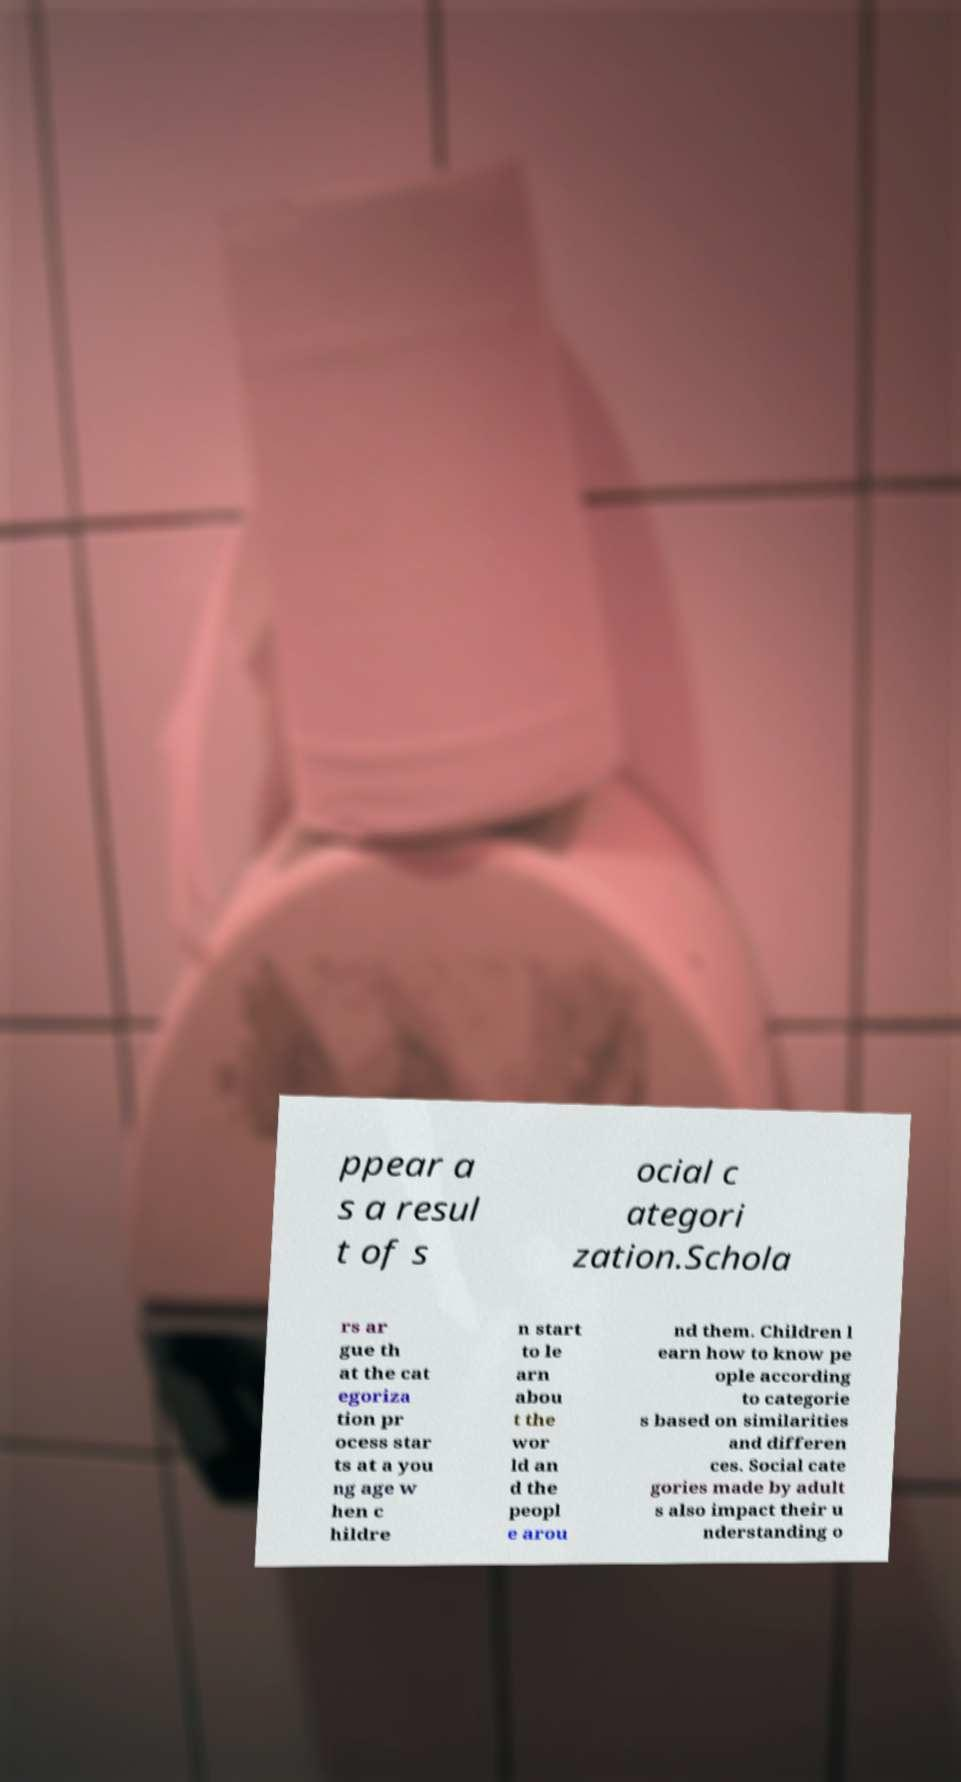What messages or text are displayed in this image? I need them in a readable, typed format. ppear a s a resul t of s ocial c ategori zation.Schola rs ar gue th at the cat egoriza tion pr ocess star ts at a you ng age w hen c hildre n start to le arn abou t the wor ld an d the peopl e arou nd them. Children l earn how to know pe ople according to categorie s based on similarities and differen ces. Social cate gories made by adult s also impact their u nderstanding o 